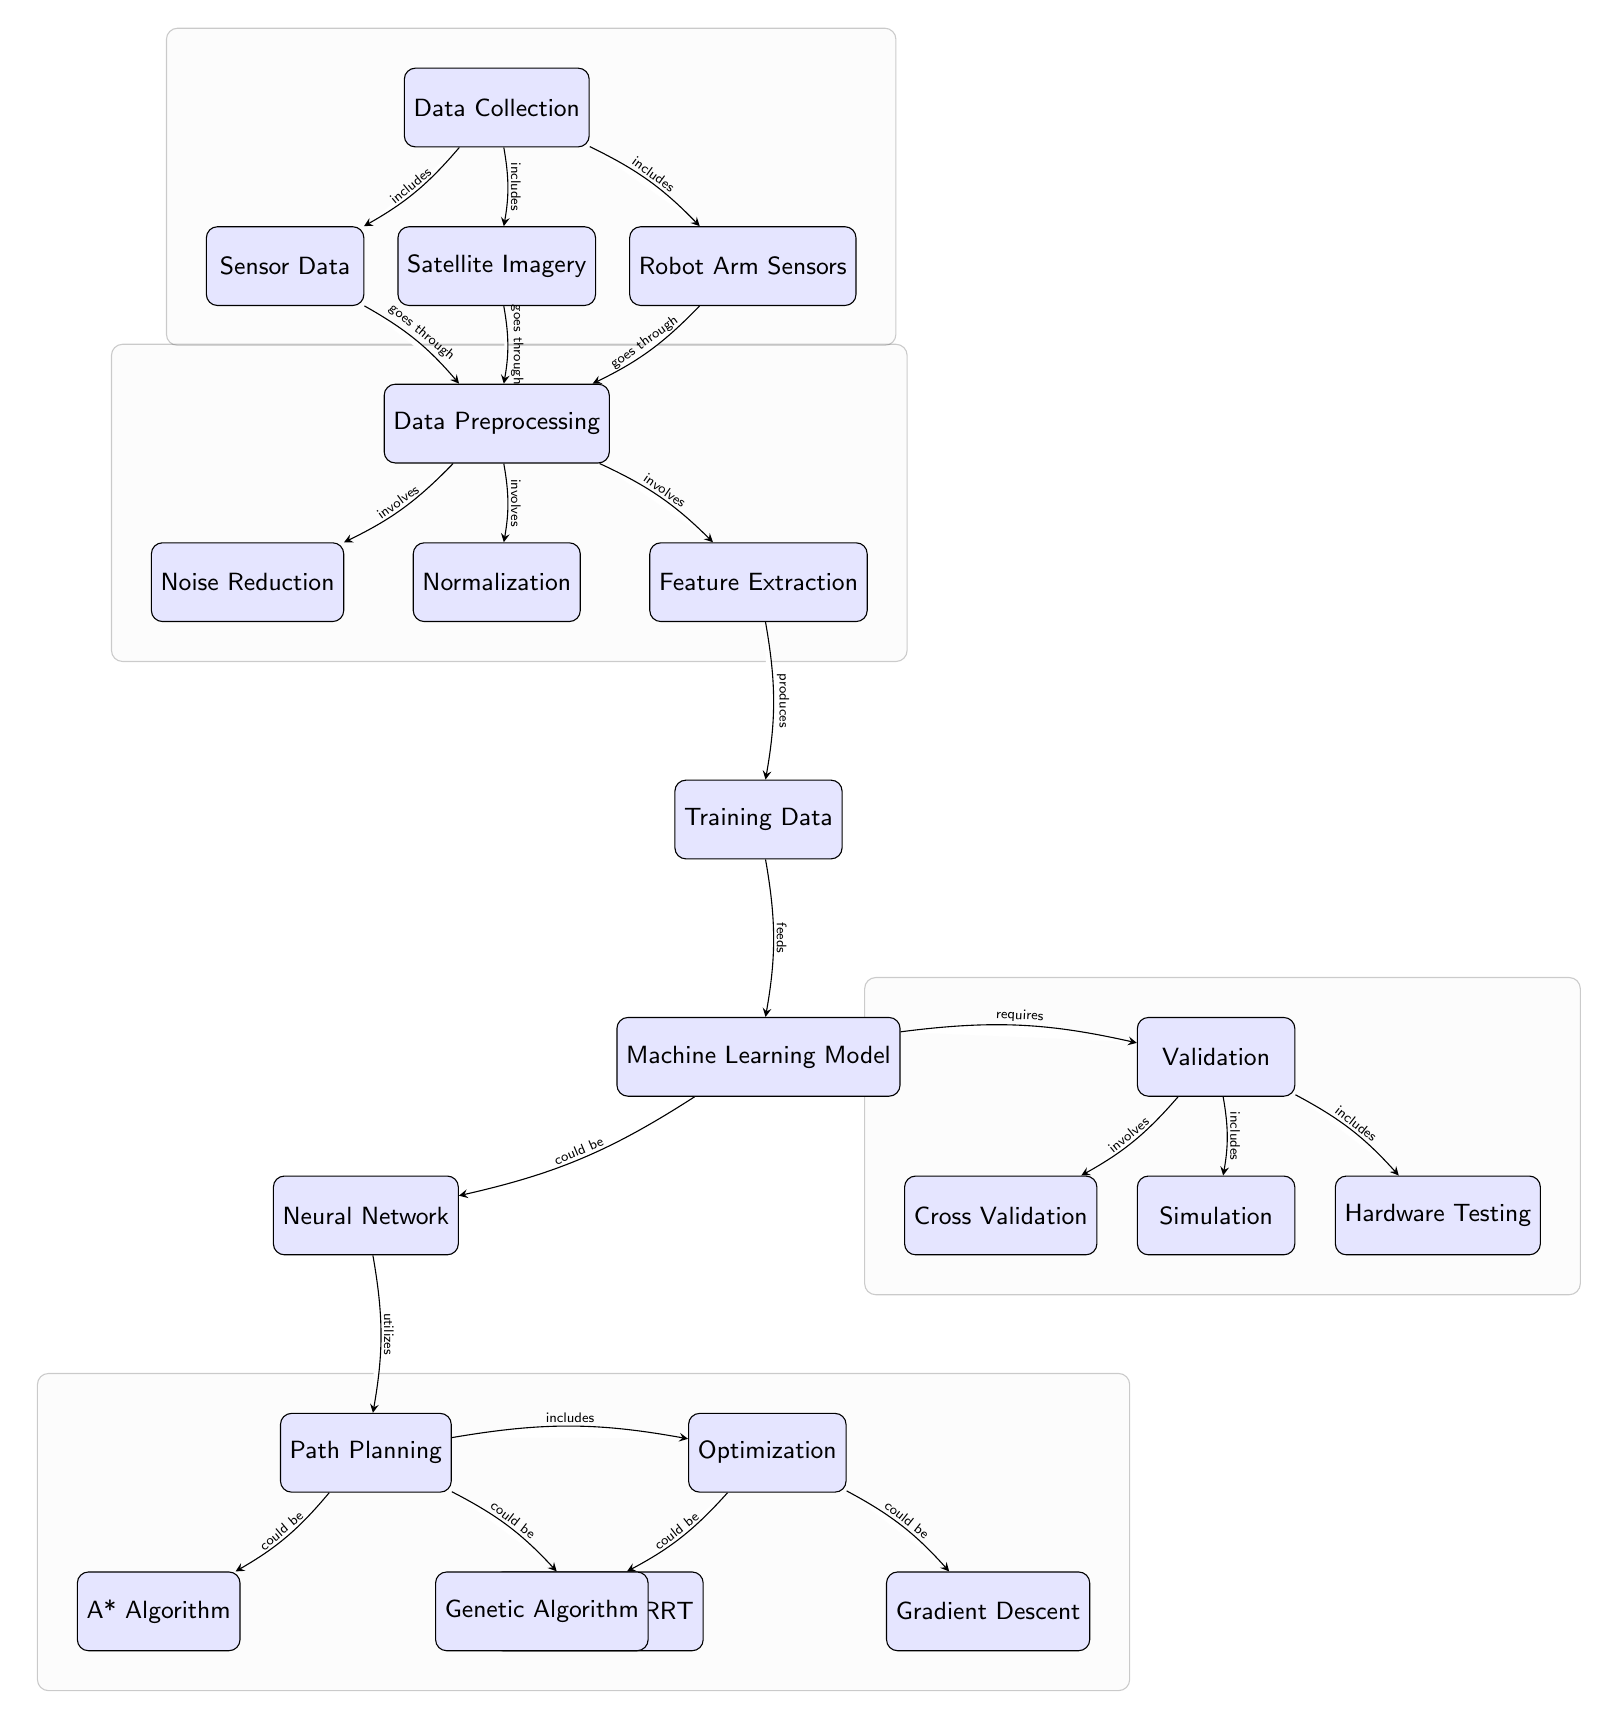What is the first step in the machine learning process shown in the diagram? The diagram starts with 'Data Collection' as the topmost node, indicating it is the initial step in the machine learning process.
Answer: Data Collection Which algorithm is listed under path planning? The diagram includes two algorithms under path planning, which are the A* algorithm and the Bidirectional RRT. Both are directly connected to the path planning node.
Answer: A* Algorithm, Bidirectional RRT How many types of validation methods are shown? The validation node lists three methods: Cross Validation, Simulation, and Hardware Testing. Counting these methods gives us a total of three distinct types of validation methods.
Answer: 3 What is the relationship between the robot arm sensors and data preprocessing? The arrow connects the 'Robot Arm Sensors' node to the 'Data Preprocessing' node, indicating that data from robot arm sensors goes through preprocessing. This implies that data collected from sensors needs to be processed before it can be used for training the model.
Answer: goes through Which optimization method is listed last in the diagram? The optimization section of the diagram includes two methods: Genetic Algorithm and Gradient Descent. Since Gradient Descent is positioned below Genetic Algorithm, it is the last method listed in the optimization section.
Answer: Gradient Descent How does feature extraction relate to training data? The arrow connects 'Feature Extraction' to 'Training Data', signifying that feature extraction produces training data that will be used in the subsequent steps of the process. This indicates a direct causative relationship between the two nodes.
Answer: produces What type of model may be used in the machine learning process? The node labeled 'Machine Learning Model' mentions a 'Neural Network' as a possible type of model that could be used in this process, indicating that it is one of the options considered.
Answer: Neural Network What is included in the optimization stage? The optimization step can consist of Genetic Algorithm and Gradient Descent as indicated by the arrows connecting these two methods to the optimization node, highlighting that these methods are part of the optimization stage.
Answer: Genetic Algorithm, Gradient Descent 